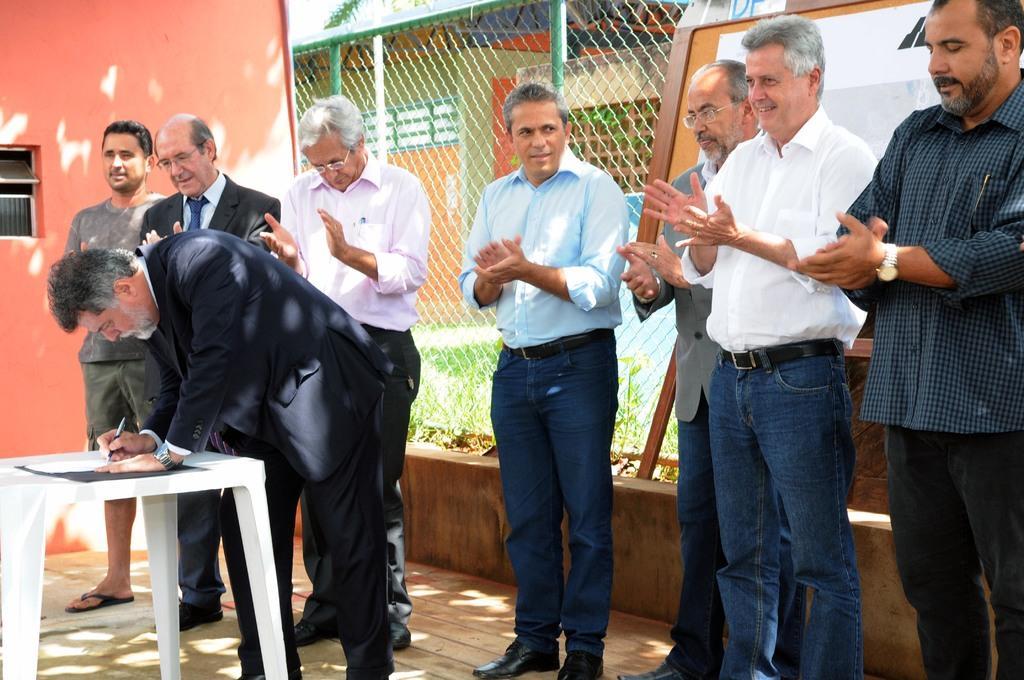Can you describe this image briefly? In this picture there are group of men standing and clapping. There is a man who is holding a pen and writing on a paper. There is a table. There is a building and a tree at the background. There is a board. 